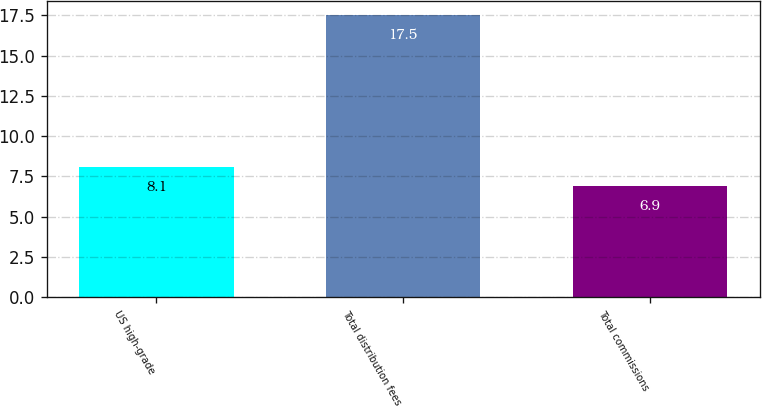Convert chart to OTSL. <chart><loc_0><loc_0><loc_500><loc_500><bar_chart><fcel>US high-grade<fcel>Total distribution fees<fcel>Total commissions<nl><fcel>8.1<fcel>17.5<fcel>6.9<nl></chart> 